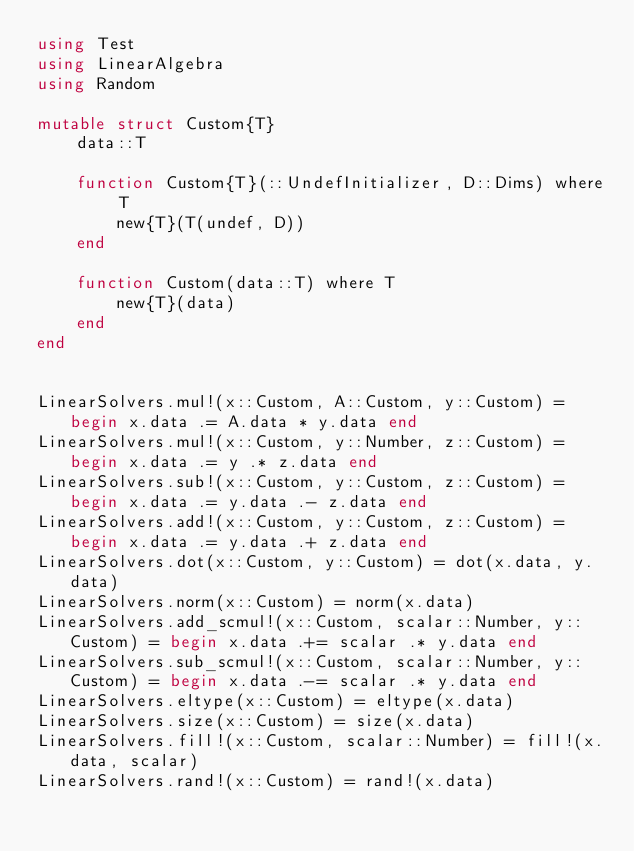<code> <loc_0><loc_0><loc_500><loc_500><_Julia_>using Test
using LinearAlgebra
using Random

mutable struct Custom{T}
    data::T

    function Custom{T}(::UndefInitializer, D::Dims) where T
        new{T}(T(undef, D))
    end

    function Custom(data::T) where T
        new{T}(data)
    end
end


LinearSolvers.mul!(x::Custom, A::Custom, y::Custom) = begin x.data .= A.data * y.data end
LinearSolvers.mul!(x::Custom, y::Number, z::Custom) = begin x.data .= y .* z.data end
LinearSolvers.sub!(x::Custom, y::Custom, z::Custom) = begin x.data .= y.data .- z.data end
LinearSolvers.add!(x::Custom, y::Custom, z::Custom) = begin x.data .= y.data .+ z.data end
LinearSolvers.dot(x::Custom, y::Custom) = dot(x.data, y.data)
LinearSolvers.norm(x::Custom) = norm(x.data)
LinearSolvers.add_scmul!(x::Custom, scalar::Number, y::Custom) = begin x.data .+= scalar .* y.data end
LinearSolvers.sub_scmul!(x::Custom, scalar::Number, y::Custom) = begin x.data .-= scalar .* y.data end
LinearSolvers.eltype(x::Custom) = eltype(x.data)
LinearSolvers.size(x::Custom) = size(x.data)
LinearSolvers.fill!(x::Custom, scalar::Number) = fill!(x.data, scalar)
LinearSolvers.rand!(x::Custom) = rand!(x.data)</code> 